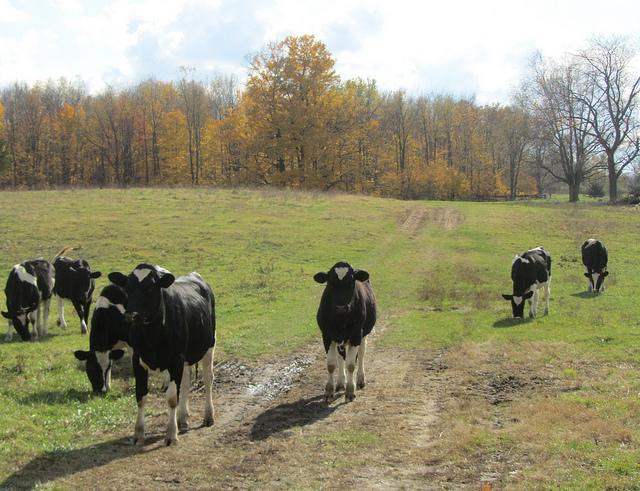What shape are the patches on the cows' foreheads?
Give a very brief answer. Triangle. Do people drive vehicles here?
Write a very short answer. Yes. How many animals are in the picture?
Give a very brief answer. 7. 